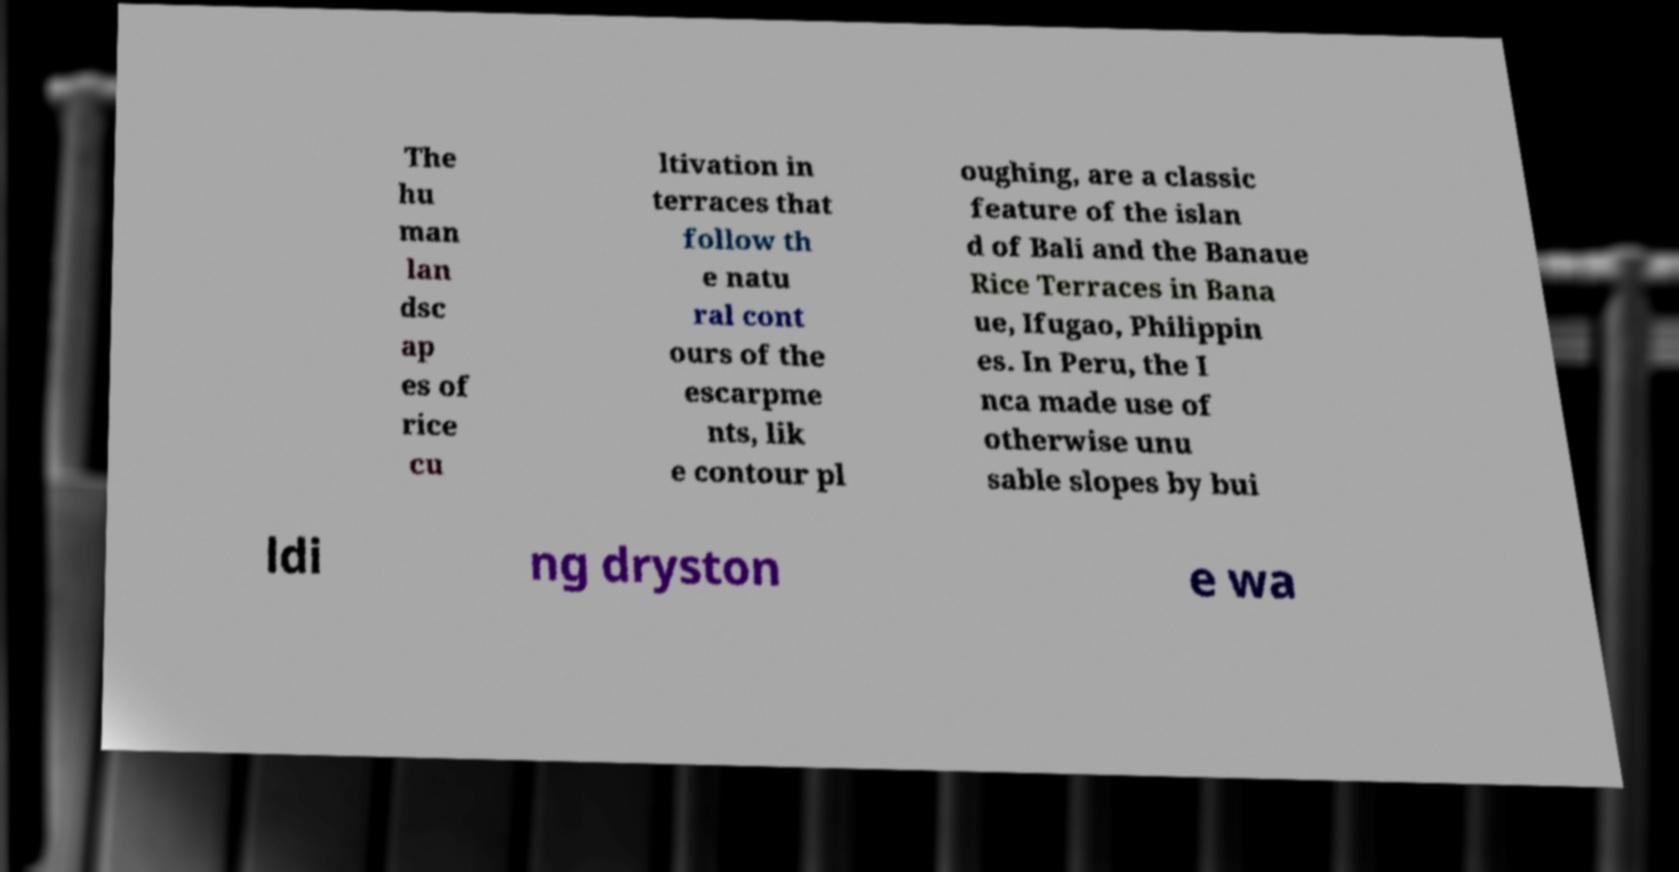Please read and relay the text visible in this image. What does it say? The hu man lan dsc ap es of rice cu ltivation in terraces that follow th e natu ral cont ours of the escarpme nts, lik e contour pl oughing, are a classic feature of the islan d of Bali and the Banaue Rice Terraces in Bana ue, Ifugao, Philippin es. In Peru, the I nca made use of otherwise unu sable slopes by bui ldi ng dryston e wa 